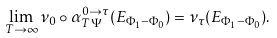Convert formula to latex. <formula><loc_0><loc_0><loc_500><loc_500>\lim _ { T \rightarrow \infty } \nu _ { 0 } \circ \alpha _ { T \Psi } ^ { 0 \to \tau } ( E _ { \Phi _ { 1 } - \Phi _ { 0 } } ) = \nu _ { \tau } ( E _ { \Phi _ { 1 } - \Phi _ { 0 } } ) .</formula> 